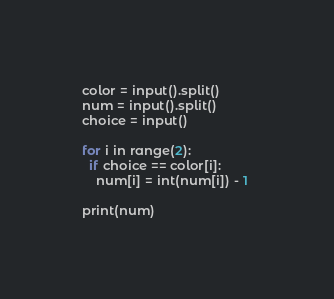<code> <loc_0><loc_0><loc_500><loc_500><_Python_>color = input().split()
num = input().split()
choice = input()

for i in range(2):
  if choice == color[i]:
    num[i] = int(num[i]) - 1 
    
print(num)</code> 